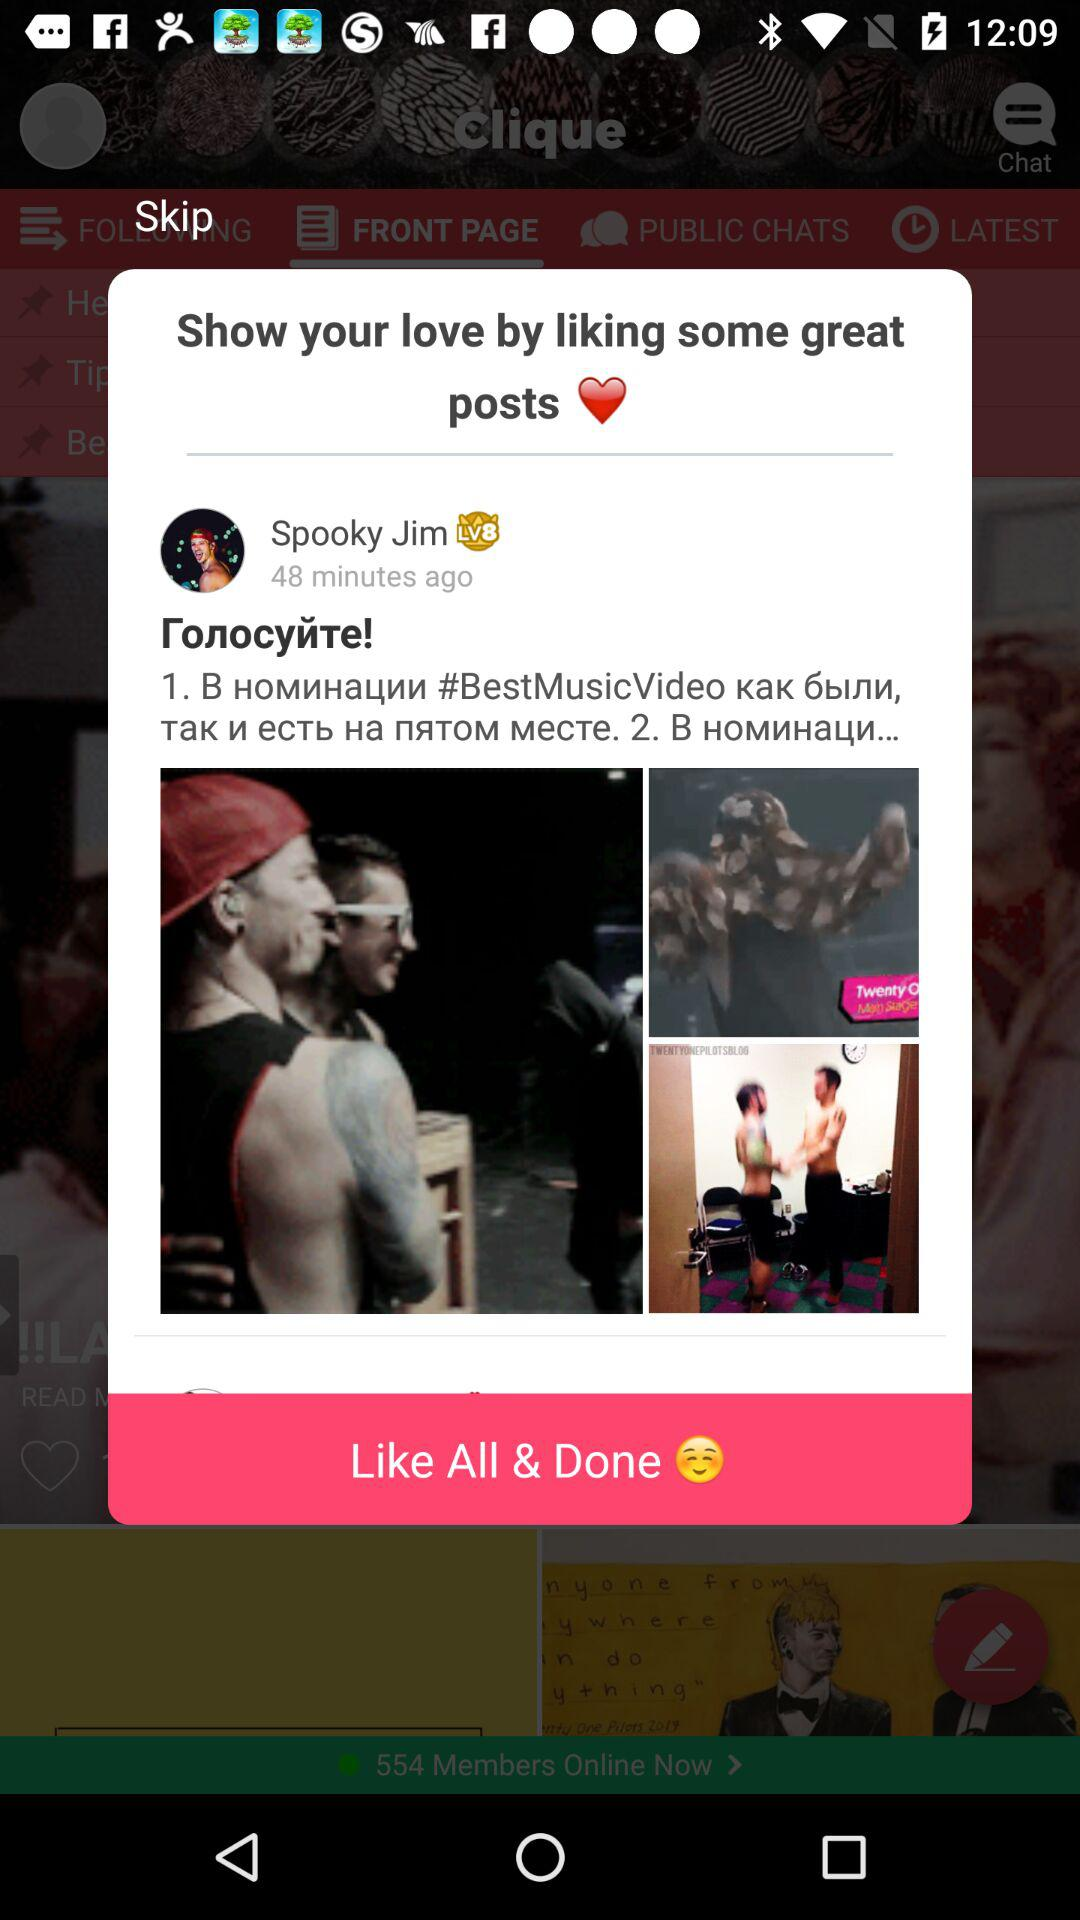How many minutes ago did it post? It was posted 48 minutes ago. 